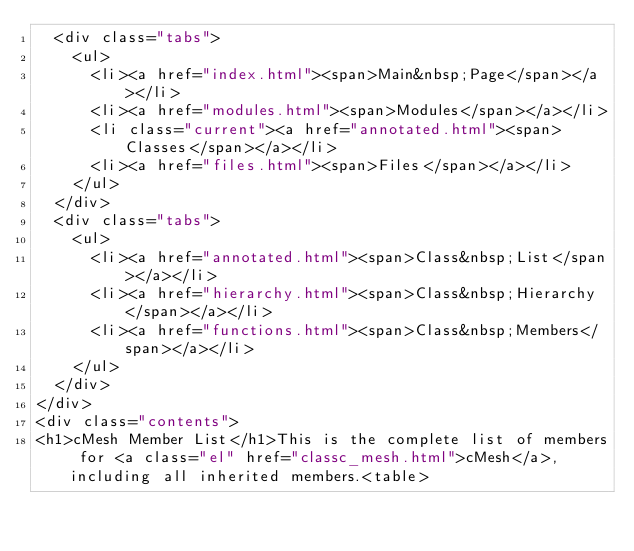Convert code to text. <code><loc_0><loc_0><loc_500><loc_500><_HTML_>  <div class="tabs">
    <ul>
      <li><a href="index.html"><span>Main&nbsp;Page</span></a></li>
      <li><a href="modules.html"><span>Modules</span></a></li>
      <li class="current"><a href="annotated.html"><span>Classes</span></a></li>
      <li><a href="files.html"><span>Files</span></a></li>
    </ul>
  </div>
  <div class="tabs">
    <ul>
      <li><a href="annotated.html"><span>Class&nbsp;List</span></a></li>
      <li><a href="hierarchy.html"><span>Class&nbsp;Hierarchy</span></a></li>
      <li><a href="functions.html"><span>Class&nbsp;Members</span></a></li>
    </ul>
  </div>
</div>
<div class="contents">
<h1>cMesh Member List</h1>This is the complete list of members for <a class="el" href="classc_mesh.html">cMesh</a>, including all inherited members.<table></code> 